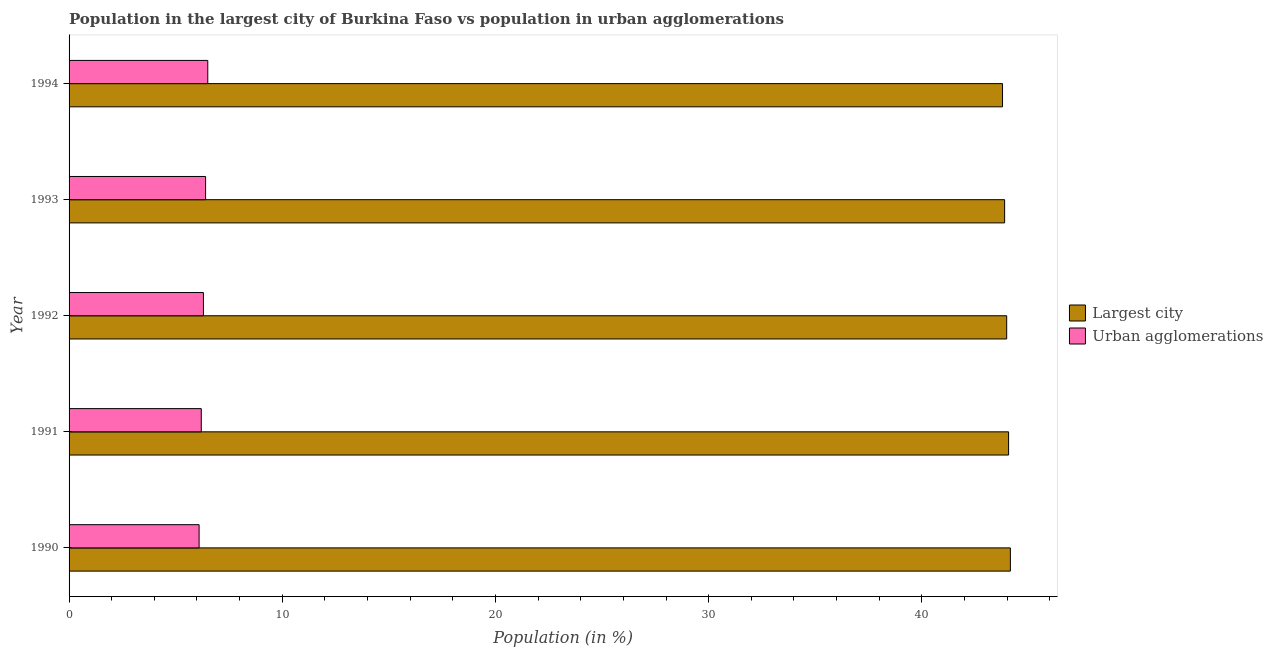How many different coloured bars are there?
Provide a succinct answer. 2. How many groups of bars are there?
Your answer should be compact. 5. Are the number of bars on each tick of the Y-axis equal?
Your answer should be compact. Yes. What is the label of the 4th group of bars from the top?
Make the answer very short. 1991. What is the population in urban agglomerations in 1991?
Provide a succinct answer. 6.2. Across all years, what is the maximum population in the largest city?
Your answer should be very brief. 44.15. Across all years, what is the minimum population in urban agglomerations?
Offer a terse response. 6.1. What is the total population in urban agglomerations in the graph?
Keep it short and to the point. 31.51. What is the difference between the population in urban agglomerations in 1992 and that in 1993?
Make the answer very short. -0.1. What is the difference between the population in urban agglomerations in 1992 and the population in the largest city in 1993?
Provide a succinct answer. -37.58. What is the average population in urban agglomerations per year?
Ensure brevity in your answer.  6.3. In the year 1992, what is the difference between the population in urban agglomerations and population in the largest city?
Give a very brief answer. -37.68. What is the ratio of the population in the largest city in 1990 to that in 1991?
Ensure brevity in your answer.  1. What is the difference between the highest and the second highest population in the largest city?
Provide a short and direct response. 0.08. What is the difference between the highest and the lowest population in the largest city?
Your answer should be very brief. 0.37. What does the 1st bar from the top in 1994 represents?
Your answer should be very brief. Urban agglomerations. What does the 1st bar from the bottom in 1990 represents?
Your response must be concise. Largest city. How many bars are there?
Give a very brief answer. 10. How many years are there in the graph?
Provide a short and direct response. 5. Are the values on the major ticks of X-axis written in scientific E-notation?
Provide a succinct answer. No. How many legend labels are there?
Provide a short and direct response. 2. How are the legend labels stacked?
Give a very brief answer. Vertical. What is the title of the graph?
Your answer should be very brief. Population in the largest city of Burkina Faso vs population in urban agglomerations. Does "Under-5(male)" appear as one of the legend labels in the graph?
Offer a very short reply. No. What is the label or title of the X-axis?
Offer a terse response. Population (in %). What is the label or title of the Y-axis?
Your response must be concise. Year. What is the Population (in %) in Largest city in 1990?
Offer a very short reply. 44.15. What is the Population (in %) of Urban agglomerations in 1990?
Offer a very short reply. 6.1. What is the Population (in %) of Largest city in 1991?
Offer a terse response. 44.07. What is the Population (in %) of Urban agglomerations in 1991?
Your answer should be compact. 6.2. What is the Population (in %) in Largest city in 1992?
Keep it short and to the point. 43.98. What is the Population (in %) of Urban agglomerations in 1992?
Your answer should be very brief. 6.3. What is the Population (in %) in Largest city in 1993?
Offer a terse response. 43.88. What is the Population (in %) in Urban agglomerations in 1993?
Make the answer very short. 6.4. What is the Population (in %) in Largest city in 1994?
Make the answer very short. 43.78. What is the Population (in %) of Urban agglomerations in 1994?
Your answer should be very brief. 6.51. Across all years, what is the maximum Population (in %) in Largest city?
Give a very brief answer. 44.15. Across all years, what is the maximum Population (in %) of Urban agglomerations?
Your response must be concise. 6.51. Across all years, what is the minimum Population (in %) of Largest city?
Offer a very short reply. 43.78. Across all years, what is the minimum Population (in %) in Urban agglomerations?
Give a very brief answer. 6.1. What is the total Population (in %) in Largest city in the graph?
Keep it short and to the point. 219.87. What is the total Population (in %) of Urban agglomerations in the graph?
Offer a very short reply. 31.51. What is the difference between the Population (in %) of Largest city in 1990 and that in 1991?
Offer a very short reply. 0.08. What is the difference between the Population (in %) of Urban agglomerations in 1990 and that in 1991?
Offer a terse response. -0.1. What is the difference between the Population (in %) of Largest city in 1990 and that in 1992?
Your answer should be very brief. 0.17. What is the difference between the Population (in %) in Urban agglomerations in 1990 and that in 1992?
Make the answer very short. -0.2. What is the difference between the Population (in %) of Largest city in 1990 and that in 1993?
Your answer should be compact. 0.27. What is the difference between the Population (in %) of Urban agglomerations in 1990 and that in 1993?
Your response must be concise. -0.3. What is the difference between the Population (in %) of Largest city in 1990 and that in 1994?
Your answer should be very brief. 0.37. What is the difference between the Population (in %) in Urban agglomerations in 1990 and that in 1994?
Offer a very short reply. -0.41. What is the difference between the Population (in %) in Largest city in 1991 and that in 1992?
Your response must be concise. 0.09. What is the difference between the Population (in %) of Urban agglomerations in 1991 and that in 1992?
Provide a succinct answer. -0.1. What is the difference between the Population (in %) of Largest city in 1991 and that in 1993?
Ensure brevity in your answer.  0.19. What is the difference between the Population (in %) in Urban agglomerations in 1991 and that in 1993?
Your response must be concise. -0.2. What is the difference between the Population (in %) of Largest city in 1991 and that in 1994?
Offer a terse response. 0.28. What is the difference between the Population (in %) in Urban agglomerations in 1991 and that in 1994?
Keep it short and to the point. -0.31. What is the difference between the Population (in %) in Largest city in 1992 and that in 1993?
Your answer should be compact. 0.1. What is the difference between the Population (in %) in Urban agglomerations in 1992 and that in 1993?
Provide a succinct answer. -0.1. What is the difference between the Population (in %) of Largest city in 1992 and that in 1994?
Give a very brief answer. 0.19. What is the difference between the Population (in %) in Urban agglomerations in 1992 and that in 1994?
Offer a very short reply. -0.2. What is the difference between the Population (in %) of Largest city in 1993 and that in 1994?
Your answer should be compact. 0.1. What is the difference between the Population (in %) of Urban agglomerations in 1993 and that in 1994?
Give a very brief answer. -0.1. What is the difference between the Population (in %) in Largest city in 1990 and the Population (in %) in Urban agglomerations in 1991?
Provide a succinct answer. 37.95. What is the difference between the Population (in %) of Largest city in 1990 and the Population (in %) of Urban agglomerations in 1992?
Keep it short and to the point. 37.85. What is the difference between the Population (in %) of Largest city in 1990 and the Population (in %) of Urban agglomerations in 1993?
Your response must be concise. 37.75. What is the difference between the Population (in %) in Largest city in 1990 and the Population (in %) in Urban agglomerations in 1994?
Provide a succinct answer. 37.65. What is the difference between the Population (in %) in Largest city in 1991 and the Population (in %) in Urban agglomerations in 1992?
Your answer should be compact. 37.77. What is the difference between the Population (in %) in Largest city in 1991 and the Population (in %) in Urban agglomerations in 1993?
Offer a terse response. 37.66. What is the difference between the Population (in %) of Largest city in 1991 and the Population (in %) of Urban agglomerations in 1994?
Ensure brevity in your answer.  37.56. What is the difference between the Population (in %) of Largest city in 1992 and the Population (in %) of Urban agglomerations in 1993?
Provide a short and direct response. 37.58. What is the difference between the Population (in %) in Largest city in 1992 and the Population (in %) in Urban agglomerations in 1994?
Provide a short and direct response. 37.47. What is the difference between the Population (in %) of Largest city in 1993 and the Population (in %) of Urban agglomerations in 1994?
Ensure brevity in your answer.  37.38. What is the average Population (in %) of Largest city per year?
Offer a very short reply. 43.97. What is the average Population (in %) of Urban agglomerations per year?
Give a very brief answer. 6.3. In the year 1990, what is the difference between the Population (in %) in Largest city and Population (in %) in Urban agglomerations?
Your answer should be very brief. 38.05. In the year 1991, what is the difference between the Population (in %) in Largest city and Population (in %) in Urban agglomerations?
Your answer should be compact. 37.87. In the year 1992, what is the difference between the Population (in %) in Largest city and Population (in %) in Urban agglomerations?
Offer a very short reply. 37.68. In the year 1993, what is the difference between the Population (in %) in Largest city and Population (in %) in Urban agglomerations?
Offer a terse response. 37.48. In the year 1994, what is the difference between the Population (in %) of Largest city and Population (in %) of Urban agglomerations?
Offer a very short reply. 37.28. What is the ratio of the Population (in %) of Urban agglomerations in 1990 to that in 1991?
Keep it short and to the point. 0.98. What is the ratio of the Population (in %) of Largest city in 1990 to that in 1992?
Give a very brief answer. 1. What is the ratio of the Population (in %) in Urban agglomerations in 1990 to that in 1992?
Provide a succinct answer. 0.97. What is the ratio of the Population (in %) in Urban agglomerations in 1990 to that in 1993?
Your answer should be compact. 0.95. What is the ratio of the Population (in %) of Largest city in 1990 to that in 1994?
Provide a short and direct response. 1.01. What is the ratio of the Population (in %) of Urban agglomerations in 1990 to that in 1994?
Offer a very short reply. 0.94. What is the ratio of the Population (in %) in Largest city in 1991 to that in 1992?
Keep it short and to the point. 1. What is the ratio of the Population (in %) in Urban agglomerations in 1991 to that in 1992?
Keep it short and to the point. 0.98. What is the ratio of the Population (in %) of Largest city in 1991 to that in 1993?
Your answer should be compact. 1. What is the ratio of the Population (in %) of Urban agglomerations in 1991 to that in 1993?
Keep it short and to the point. 0.97. What is the ratio of the Population (in %) of Urban agglomerations in 1991 to that in 1994?
Your response must be concise. 0.95. What is the ratio of the Population (in %) of Urban agglomerations in 1992 to that in 1993?
Your answer should be very brief. 0.98. What is the ratio of the Population (in %) of Urban agglomerations in 1992 to that in 1994?
Make the answer very short. 0.97. What is the ratio of the Population (in %) of Urban agglomerations in 1993 to that in 1994?
Offer a very short reply. 0.98. What is the difference between the highest and the second highest Population (in %) in Largest city?
Offer a terse response. 0.08. What is the difference between the highest and the second highest Population (in %) of Urban agglomerations?
Your answer should be very brief. 0.1. What is the difference between the highest and the lowest Population (in %) in Largest city?
Provide a succinct answer. 0.37. What is the difference between the highest and the lowest Population (in %) in Urban agglomerations?
Your answer should be very brief. 0.41. 